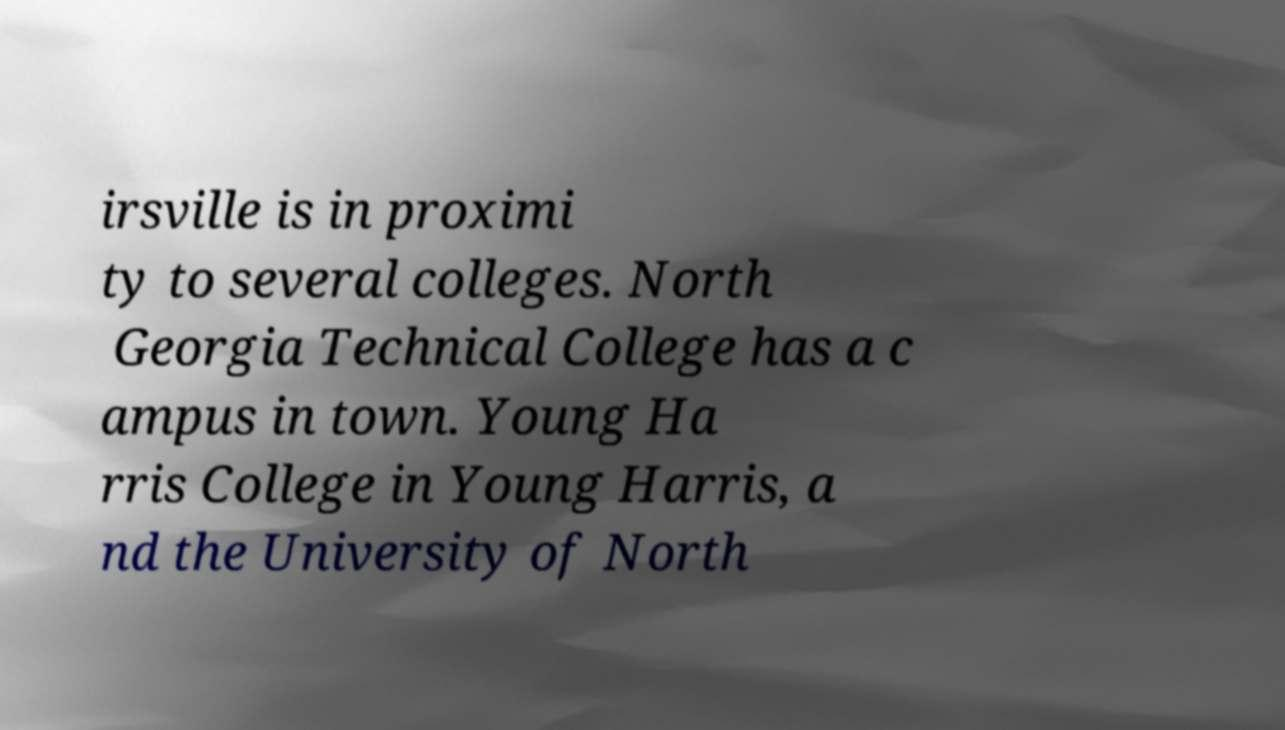Could you assist in decoding the text presented in this image and type it out clearly? irsville is in proximi ty to several colleges. North Georgia Technical College has a c ampus in town. Young Ha rris College in Young Harris, a nd the University of North 